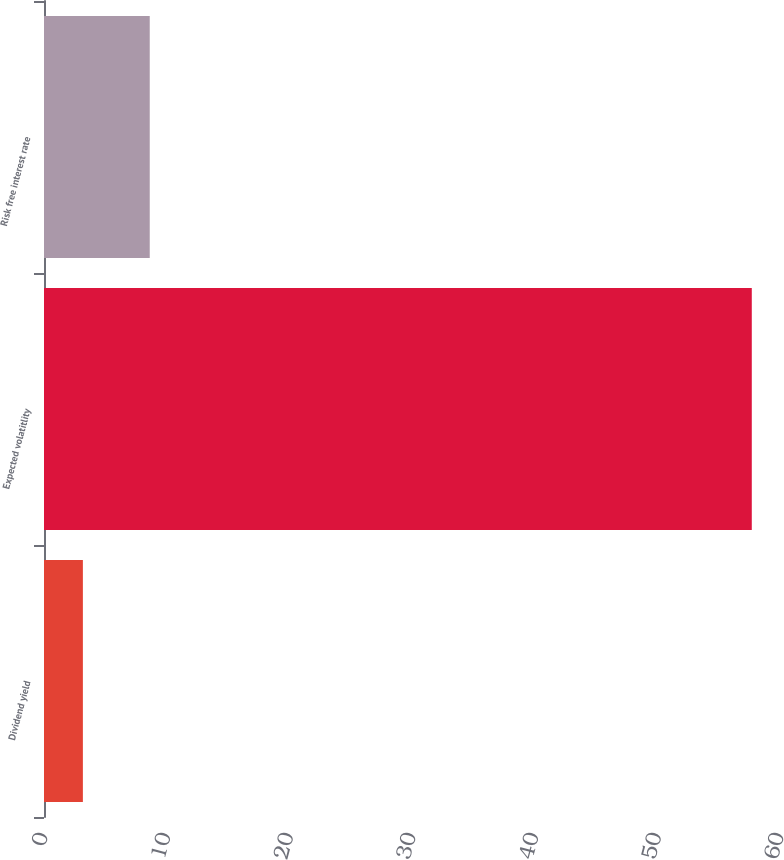Convert chart to OTSL. <chart><loc_0><loc_0><loc_500><loc_500><bar_chart><fcel>Dividend yield<fcel>Expected volatitlity<fcel>Risk free interest rate<nl><fcel>3.17<fcel>57.7<fcel>8.62<nl></chart> 